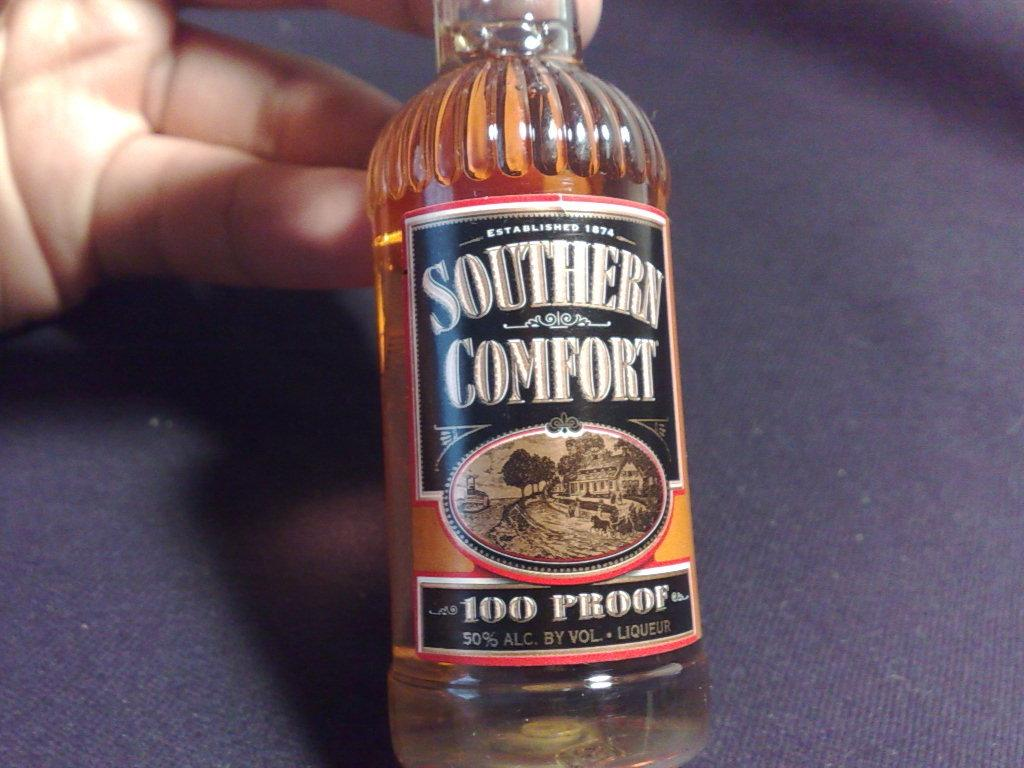<image>
Describe the image concisely. A bottle of Southern Comfort with is 100 proof. 